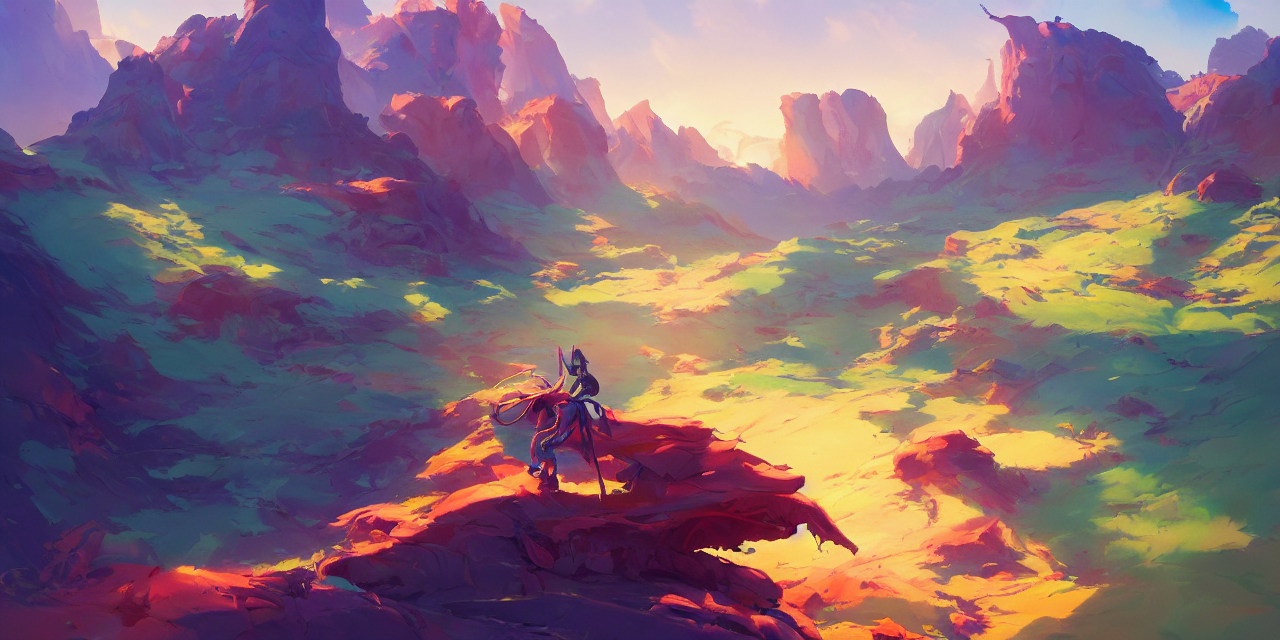What time of day does this scene depict? The warm hues bathing the landscape suggest this scene depicts either a vibrant sunrise or a colorful sunset, casting dynamic shadows and contributing to the dreamlike quality of the vista. 